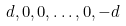<formula> <loc_0><loc_0><loc_500><loc_500>d , 0 , 0 , \dots , 0 , - d</formula> 